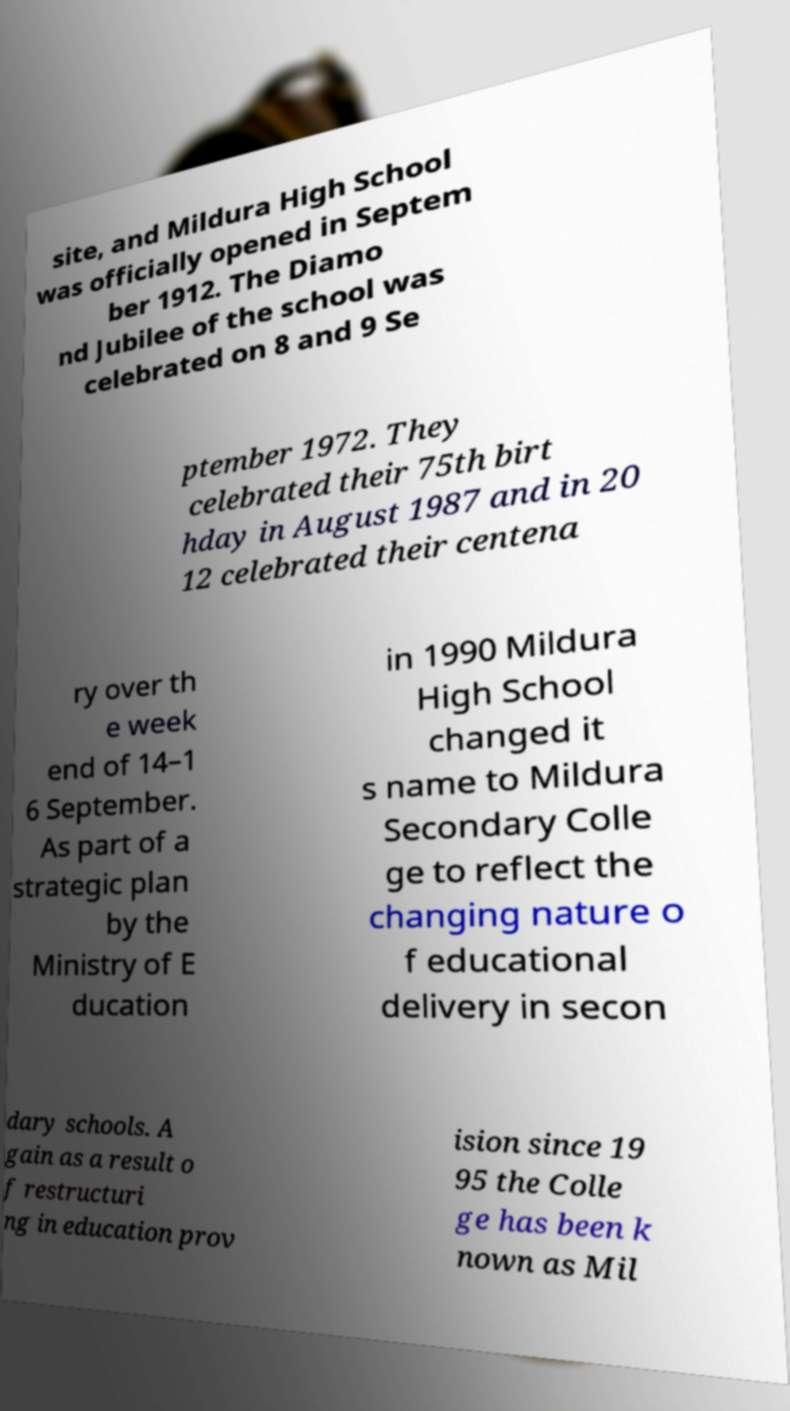Can you read and provide the text displayed in the image?This photo seems to have some interesting text. Can you extract and type it out for me? site, and Mildura High School was officially opened in Septem ber 1912. The Diamo nd Jubilee of the school was celebrated on 8 and 9 Se ptember 1972. They celebrated their 75th birt hday in August 1987 and in 20 12 celebrated their centena ry over th e week end of 14–1 6 September. As part of a strategic plan by the Ministry of E ducation in 1990 Mildura High School changed it s name to Mildura Secondary Colle ge to reflect the changing nature o f educational delivery in secon dary schools. A gain as a result o f restructuri ng in education prov ision since 19 95 the Colle ge has been k nown as Mil 